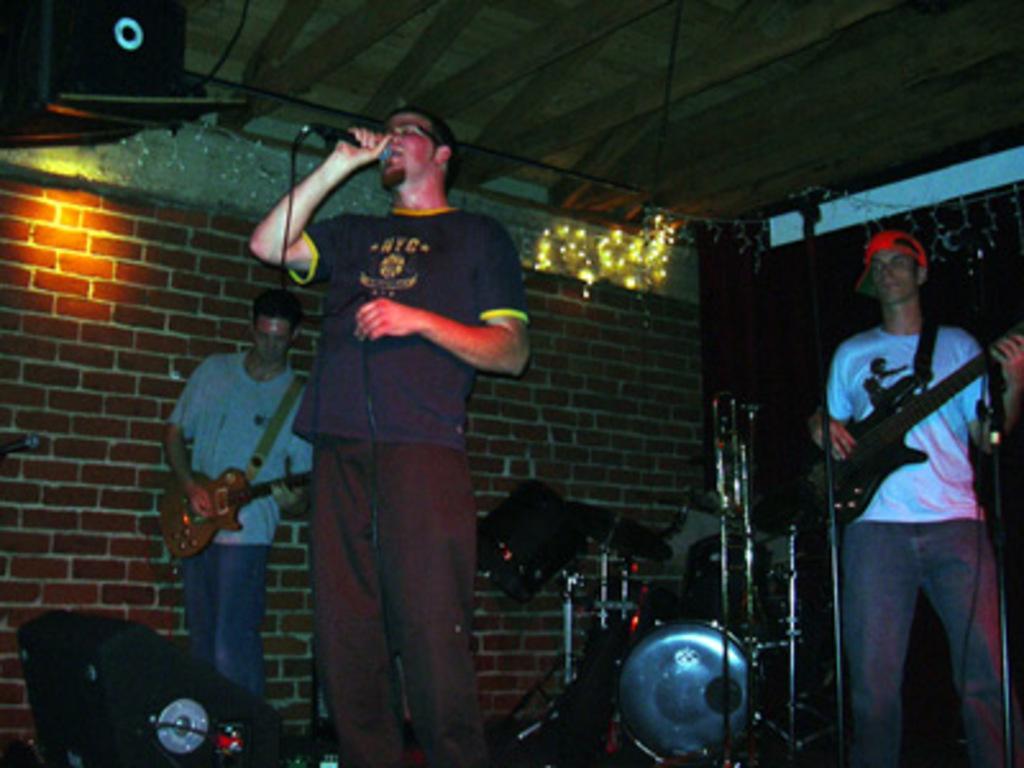Could you give a brief overview of what you see in this image? This image consist of three men performing music. In the front, there is a man wearing blue t-shirt and singing. To the right, there is a man wearing white t-shirt and playing guitar. In the background, there is a band and wall. At the top, there is a roof made up of wood. 